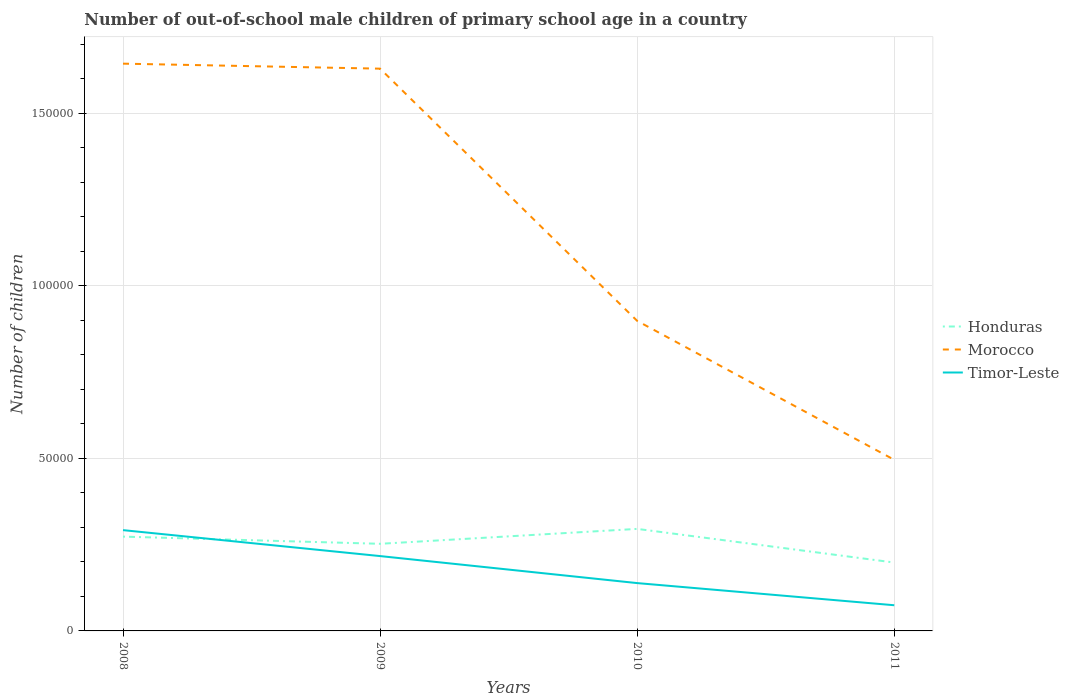How many different coloured lines are there?
Provide a short and direct response. 3. Across all years, what is the maximum number of out-of-school male children in Morocco?
Provide a short and direct response. 4.96e+04. What is the total number of out-of-school male children in Timor-Leste in the graph?
Make the answer very short. 7518. What is the difference between the highest and the second highest number of out-of-school male children in Morocco?
Make the answer very short. 1.15e+05. What is the difference between the highest and the lowest number of out-of-school male children in Morocco?
Give a very brief answer. 2. Are the values on the major ticks of Y-axis written in scientific E-notation?
Your response must be concise. No. Does the graph contain any zero values?
Keep it short and to the point. No. Where does the legend appear in the graph?
Offer a very short reply. Center right. How many legend labels are there?
Ensure brevity in your answer.  3. What is the title of the graph?
Your answer should be very brief. Number of out-of-school male children of primary school age in a country. Does "Sri Lanka" appear as one of the legend labels in the graph?
Offer a terse response. No. What is the label or title of the Y-axis?
Your answer should be compact. Number of children. What is the Number of children of Honduras in 2008?
Offer a terse response. 2.73e+04. What is the Number of children of Morocco in 2008?
Your answer should be compact. 1.64e+05. What is the Number of children of Timor-Leste in 2008?
Give a very brief answer. 2.92e+04. What is the Number of children in Honduras in 2009?
Your answer should be compact. 2.52e+04. What is the Number of children in Morocco in 2009?
Offer a very short reply. 1.63e+05. What is the Number of children of Timor-Leste in 2009?
Provide a short and direct response. 2.17e+04. What is the Number of children of Honduras in 2010?
Your answer should be very brief. 2.96e+04. What is the Number of children in Morocco in 2010?
Make the answer very short. 8.99e+04. What is the Number of children in Timor-Leste in 2010?
Offer a very short reply. 1.39e+04. What is the Number of children in Honduras in 2011?
Keep it short and to the point. 1.98e+04. What is the Number of children of Morocco in 2011?
Your answer should be very brief. 4.96e+04. What is the Number of children in Timor-Leste in 2011?
Offer a very short reply. 7443. Across all years, what is the maximum Number of children in Honduras?
Make the answer very short. 2.96e+04. Across all years, what is the maximum Number of children in Morocco?
Provide a succinct answer. 1.64e+05. Across all years, what is the maximum Number of children of Timor-Leste?
Keep it short and to the point. 2.92e+04. Across all years, what is the minimum Number of children in Honduras?
Ensure brevity in your answer.  1.98e+04. Across all years, what is the minimum Number of children of Morocco?
Provide a short and direct response. 4.96e+04. Across all years, what is the minimum Number of children of Timor-Leste?
Keep it short and to the point. 7443. What is the total Number of children in Honduras in the graph?
Offer a very short reply. 1.02e+05. What is the total Number of children in Morocco in the graph?
Provide a succinct answer. 4.67e+05. What is the total Number of children of Timor-Leste in the graph?
Your answer should be very brief. 7.22e+04. What is the difference between the Number of children of Honduras in 2008 and that in 2009?
Your answer should be very brief. 2082. What is the difference between the Number of children in Morocco in 2008 and that in 2009?
Ensure brevity in your answer.  1451. What is the difference between the Number of children of Timor-Leste in 2008 and that in 2009?
Provide a succinct answer. 7518. What is the difference between the Number of children in Honduras in 2008 and that in 2010?
Provide a succinct answer. -2241. What is the difference between the Number of children of Morocco in 2008 and that in 2010?
Keep it short and to the point. 7.46e+04. What is the difference between the Number of children in Timor-Leste in 2008 and that in 2010?
Offer a terse response. 1.53e+04. What is the difference between the Number of children in Honduras in 2008 and that in 2011?
Provide a short and direct response. 7513. What is the difference between the Number of children in Morocco in 2008 and that in 2011?
Your answer should be very brief. 1.15e+05. What is the difference between the Number of children in Timor-Leste in 2008 and that in 2011?
Keep it short and to the point. 2.18e+04. What is the difference between the Number of children in Honduras in 2009 and that in 2010?
Give a very brief answer. -4323. What is the difference between the Number of children of Morocco in 2009 and that in 2010?
Ensure brevity in your answer.  7.31e+04. What is the difference between the Number of children in Timor-Leste in 2009 and that in 2010?
Keep it short and to the point. 7830. What is the difference between the Number of children of Honduras in 2009 and that in 2011?
Your response must be concise. 5431. What is the difference between the Number of children in Morocco in 2009 and that in 2011?
Your response must be concise. 1.13e+05. What is the difference between the Number of children in Timor-Leste in 2009 and that in 2011?
Offer a very short reply. 1.42e+04. What is the difference between the Number of children in Honduras in 2010 and that in 2011?
Your answer should be compact. 9754. What is the difference between the Number of children of Morocco in 2010 and that in 2011?
Your answer should be very brief. 4.03e+04. What is the difference between the Number of children in Timor-Leste in 2010 and that in 2011?
Keep it short and to the point. 6419. What is the difference between the Number of children in Honduras in 2008 and the Number of children in Morocco in 2009?
Your answer should be very brief. -1.36e+05. What is the difference between the Number of children in Honduras in 2008 and the Number of children in Timor-Leste in 2009?
Keep it short and to the point. 5639. What is the difference between the Number of children in Morocco in 2008 and the Number of children in Timor-Leste in 2009?
Ensure brevity in your answer.  1.43e+05. What is the difference between the Number of children in Honduras in 2008 and the Number of children in Morocco in 2010?
Keep it short and to the point. -6.25e+04. What is the difference between the Number of children of Honduras in 2008 and the Number of children of Timor-Leste in 2010?
Provide a succinct answer. 1.35e+04. What is the difference between the Number of children in Morocco in 2008 and the Number of children in Timor-Leste in 2010?
Make the answer very short. 1.51e+05. What is the difference between the Number of children in Honduras in 2008 and the Number of children in Morocco in 2011?
Provide a short and direct response. -2.23e+04. What is the difference between the Number of children of Honduras in 2008 and the Number of children of Timor-Leste in 2011?
Provide a short and direct response. 1.99e+04. What is the difference between the Number of children in Morocco in 2008 and the Number of children in Timor-Leste in 2011?
Your response must be concise. 1.57e+05. What is the difference between the Number of children in Honduras in 2009 and the Number of children in Morocco in 2010?
Provide a short and direct response. -6.46e+04. What is the difference between the Number of children in Honduras in 2009 and the Number of children in Timor-Leste in 2010?
Your answer should be compact. 1.14e+04. What is the difference between the Number of children of Morocco in 2009 and the Number of children of Timor-Leste in 2010?
Make the answer very short. 1.49e+05. What is the difference between the Number of children of Honduras in 2009 and the Number of children of Morocco in 2011?
Provide a succinct answer. -2.43e+04. What is the difference between the Number of children of Honduras in 2009 and the Number of children of Timor-Leste in 2011?
Make the answer very short. 1.78e+04. What is the difference between the Number of children in Morocco in 2009 and the Number of children in Timor-Leste in 2011?
Give a very brief answer. 1.56e+05. What is the difference between the Number of children in Honduras in 2010 and the Number of children in Morocco in 2011?
Make the answer very short. -2.00e+04. What is the difference between the Number of children in Honduras in 2010 and the Number of children in Timor-Leste in 2011?
Ensure brevity in your answer.  2.21e+04. What is the difference between the Number of children in Morocco in 2010 and the Number of children in Timor-Leste in 2011?
Ensure brevity in your answer.  8.24e+04. What is the average Number of children of Honduras per year?
Ensure brevity in your answer.  2.55e+04. What is the average Number of children in Morocco per year?
Make the answer very short. 1.17e+05. What is the average Number of children in Timor-Leste per year?
Provide a short and direct response. 1.81e+04. In the year 2008, what is the difference between the Number of children in Honduras and Number of children in Morocco?
Your response must be concise. -1.37e+05. In the year 2008, what is the difference between the Number of children of Honduras and Number of children of Timor-Leste?
Keep it short and to the point. -1879. In the year 2008, what is the difference between the Number of children in Morocco and Number of children in Timor-Leste?
Keep it short and to the point. 1.35e+05. In the year 2009, what is the difference between the Number of children in Honduras and Number of children in Morocco?
Your answer should be compact. -1.38e+05. In the year 2009, what is the difference between the Number of children in Honduras and Number of children in Timor-Leste?
Provide a short and direct response. 3557. In the year 2009, what is the difference between the Number of children of Morocco and Number of children of Timor-Leste?
Provide a succinct answer. 1.41e+05. In the year 2010, what is the difference between the Number of children in Honduras and Number of children in Morocco?
Provide a succinct answer. -6.03e+04. In the year 2010, what is the difference between the Number of children of Honduras and Number of children of Timor-Leste?
Make the answer very short. 1.57e+04. In the year 2010, what is the difference between the Number of children in Morocco and Number of children in Timor-Leste?
Provide a short and direct response. 7.60e+04. In the year 2011, what is the difference between the Number of children in Honduras and Number of children in Morocco?
Ensure brevity in your answer.  -2.98e+04. In the year 2011, what is the difference between the Number of children of Honduras and Number of children of Timor-Leste?
Give a very brief answer. 1.24e+04. In the year 2011, what is the difference between the Number of children in Morocco and Number of children in Timor-Leste?
Make the answer very short. 4.21e+04. What is the ratio of the Number of children in Honduras in 2008 to that in 2009?
Your answer should be compact. 1.08. What is the ratio of the Number of children in Morocco in 2008 to that in 2009?
Offer a very short reply. 1.01. What is the ratio of the Number of children of Timor-Leste in 2008 to that in 2009?
Offer a terse response. 1.35. What is the ratio of the Number of children in Honduras in 2008 to that in 2010?
Ensure brevity in your answer.  0.92. What is the ratio of the Number of children in Morocco in 2008 to that in 2010?
Your answer should be compact. 1.83. What is the ratio of the Number of children of Timor-Leste in 2008 to that in 2010?
Ensure brevity in your answer.  2.11. What is the ratio of the Number of children in Honduras in 2008 to that in 2011?
Ensure brevity in your answer.  1.38. What is the ratio of the Number of children of Morocco in 2008 to that in 2011?
Keep it short and to the point. 3.32. What is the ratio of the Number of children of Timor-Leste in 2008 to that in 2011?
Offer a very short reply. 3.92. What is the ratio of the Number of children in Honduras in 2009 to that in 2010?
Provide a succinct answer. 0.85. What is the ratio of the Number of children of Morocco in 2009 to that in 2010?
Offer a terse response. 1.81. What is the ratio of the Number of children of Timor-Leste in 2009 to that in 2010?
Ensure brevity in your answer.  1.56. What is the ratio of the Number of children in Honduras in 2009 to that in 2011?
Provide a short and direct response. 1.27. What is the ratio of the Number of children in Morocco in 2009 to that in 2011?
Make the answer very short. 3.29. What is the ratio of the Number of children of Timor-Leste in 2009 to that in 2011?
Keep it short and to the point. 2.91. What is the ratio of the Number of children of Honduras in 2010 to that in 2011?
Your response must be concise. 1.49. What is the ratio of the Number of children in Morocco in 2010 to that in 2011?
Your answer should be very brief. 1.81. What is the ratio of the Number of children of Timor-Leste in 2010 to that in 2011?
Your answer should be compact. 1.86. What is the difference between the highest and the second highest Number of children of Honduras?
Offer a terse response. 2241. What is the difference between the highest and the second highest Number of children of Morocco?
Your answer should be very brief. 1451. What is the difference between the highest and the second highest Number of children in Timor-Leste?
Your answer should be compact. 7518. What is the difference between the highest and the lowest Number of children in Honduras?
Your answer should be very brief. 9754. What is the difference between the highest and the lowest Number of children in Morocco?
Make the answer very short. 1.15e+05. What is the difference between the highest and the lowest Number of children in Timor-Leste?
Your response must be concise. 2.18e+04. 